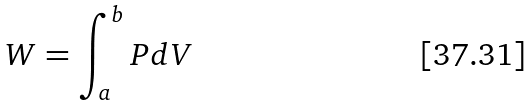Convert formula to latex. <formula><loc_0><loc_0><loc_500><loc_500>W = \int _ { a } ^ { b } P d V</formula> 